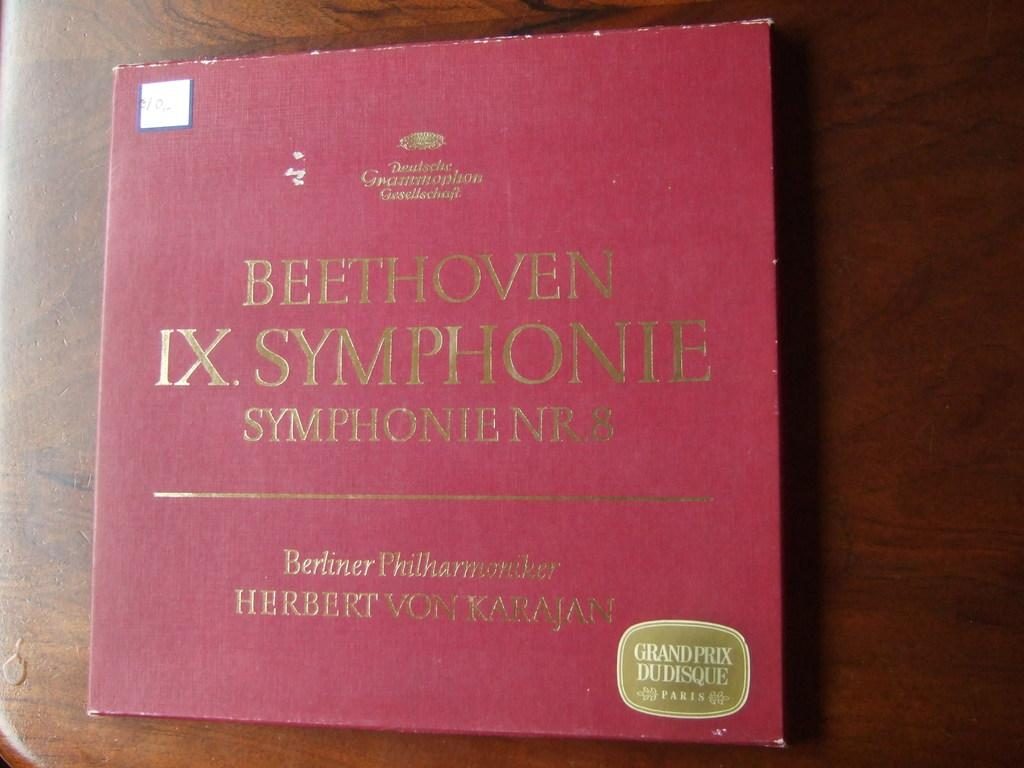<image>
Offer a succinct explanation of the picture presented. A Beethoven IX Symphonie record is sitting on a wooden table. 